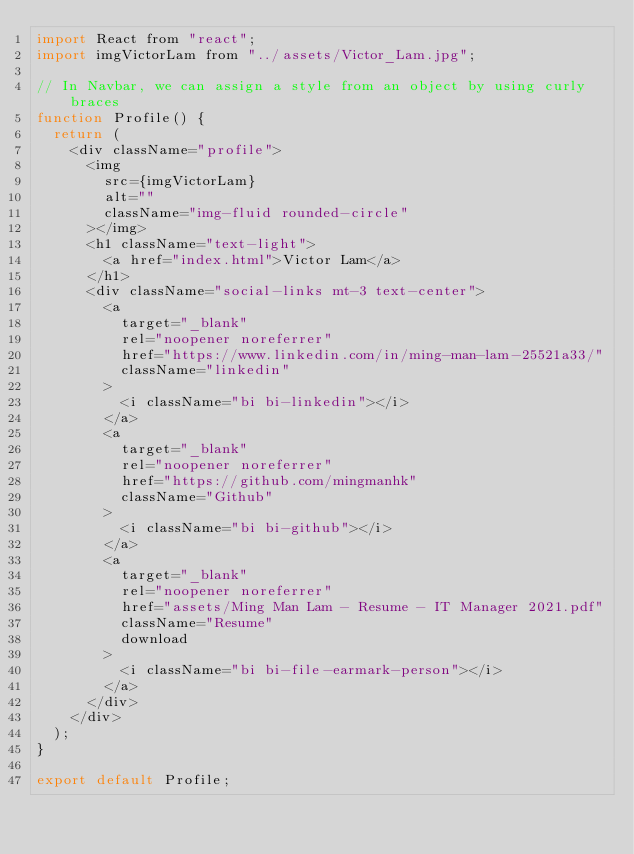<code> <loc_0><loc_0><loc_500><loc_500><_JavaScript_>import React from "react";
import imgVictorLam from "../assets/Victor_Lam.jpg";

// In Navbar, we can assign a style from an object by using curly braces
function Profile() {
  return (
    <div className="profile">
      <img
        src={imgVictorLam}
        alt=""
        className="img-fluid rounded-circle"
      ></img>
      <h1 className="text-light">
        <a href="index.html">Victor Lam</a>
      </h1>
      <div className="social-links mt-3 text-center">
        <a
          target="_blank"
          rel="noopener noreferrer"
          href="https://www.linkedin.com/in/ming-man-lam-25521a33/"
          className="linkedin"
        >
          <i className="bi bi-linkedin"></i>
        </a>
        <a
          target="_blank"
          rel="noopener noreferrer"
          href="https://github.com/mingmanhk"
          className="Github"
        >
          <i className="bi bi-github"></i>
        </a>
        <a
          target="_blank"
          rel="noopener noreferrer"
          href="assets/Ming Man Lam - Resume - IT Manager 2021.pdf"
          className="Resume"
          download
        >
          <i className="bi bi-file-earmark-person"></i>
        </a>
      </div>
    </div>
  );
}

export default Profile;
</code> 